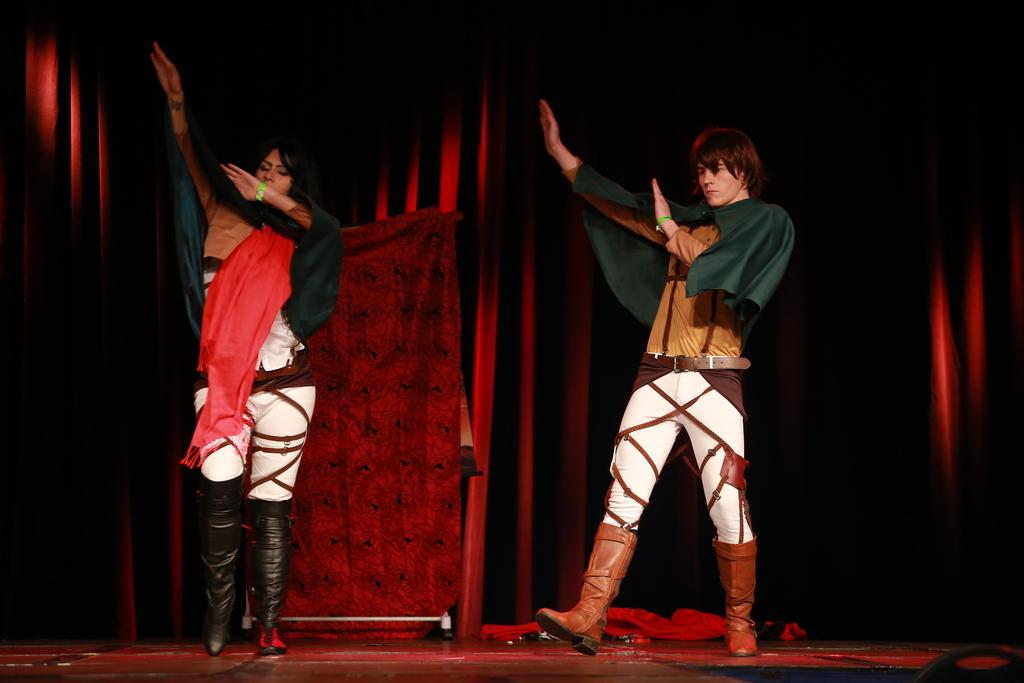What are the people in the image doing? The people in the image are dancing. Where are the people dancing? The people are dancing on the floor. What can be seen in the background of the image? There is a curtain in the background of the image. What type of stick is being used by the dancers in the image? There is no stick present in the image; the people are dancing without any props. 